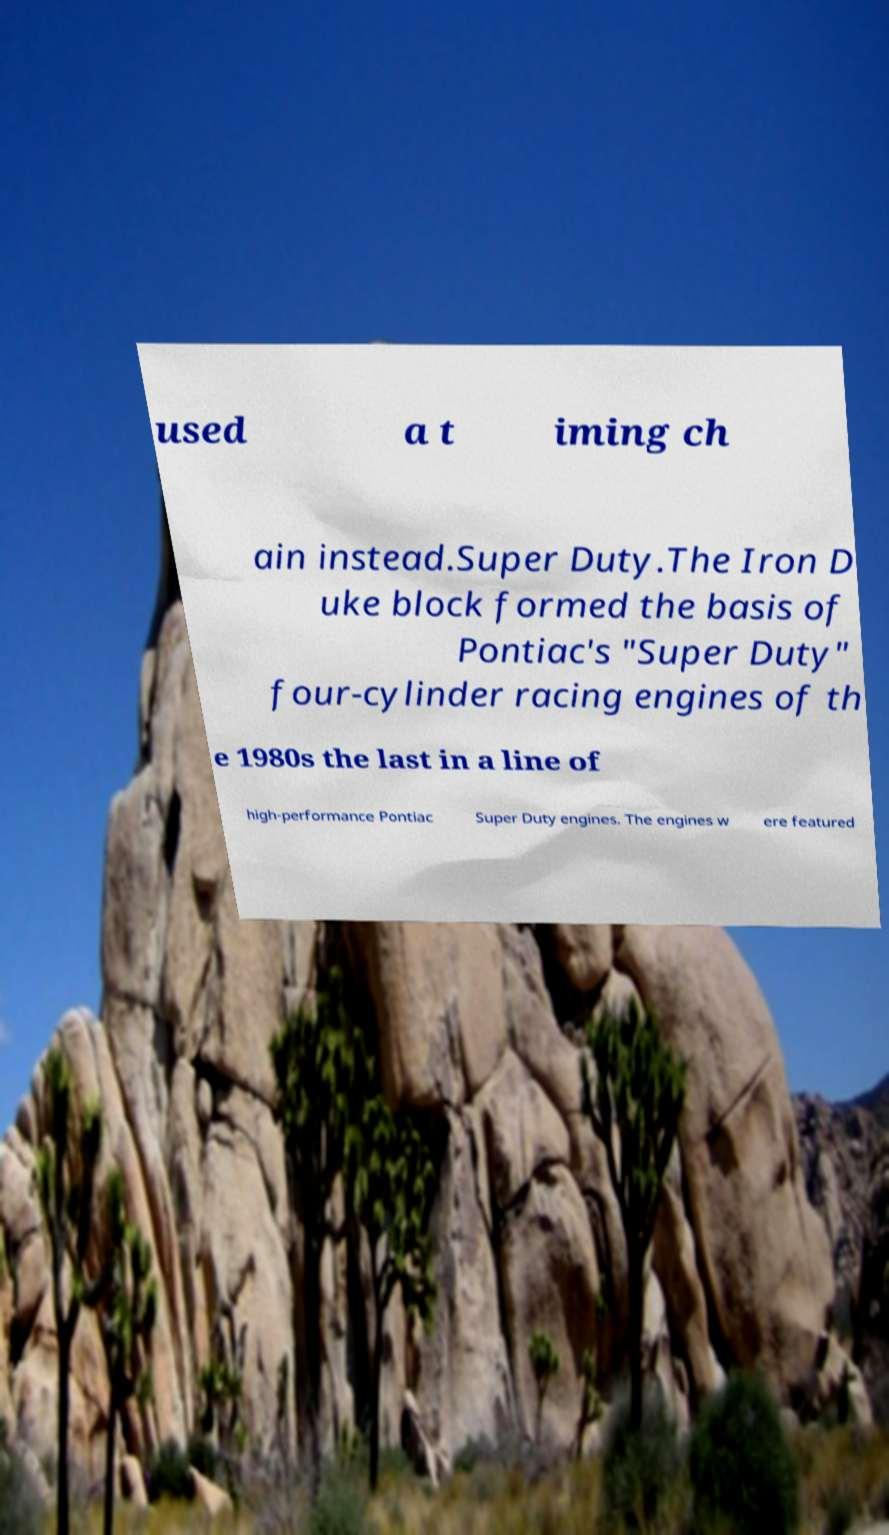Could you extract and type out the text from this image? used a t iming ch ain instead.Super Duty.The Iron D uke block formed the basis of Pontiac's "Super Duty" four-cylinder racing engines of th e 1980s the last in a line of high-performance Pontiac Super Duty engines. The engines w ere featured 